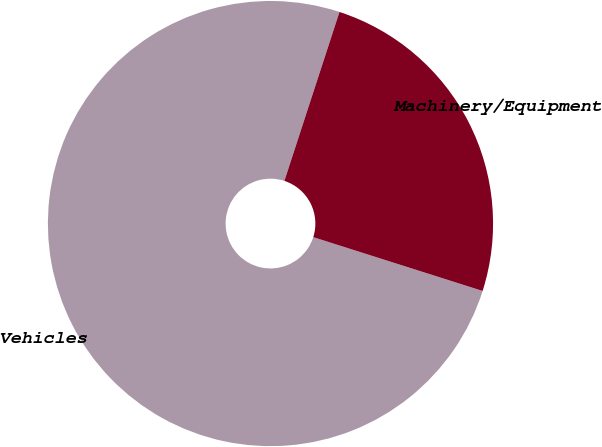<chart> <loc_0><loc_0><loc_500><loc_500><pie_chart><fcel>Vehicles<fcel>Machinery/Equipment<nl><fcel>75.12%<fcel>24.88%<nl></chart> 